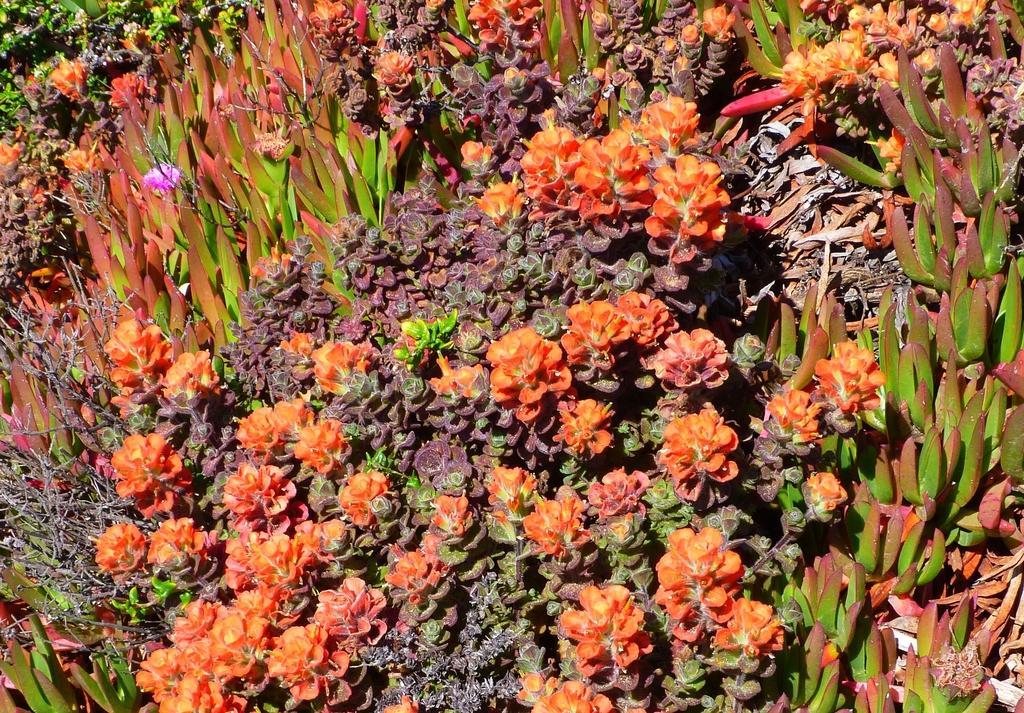Could you give a brief overview of what you see in this image? There are different types of plants. And one plant is having pink flower. 